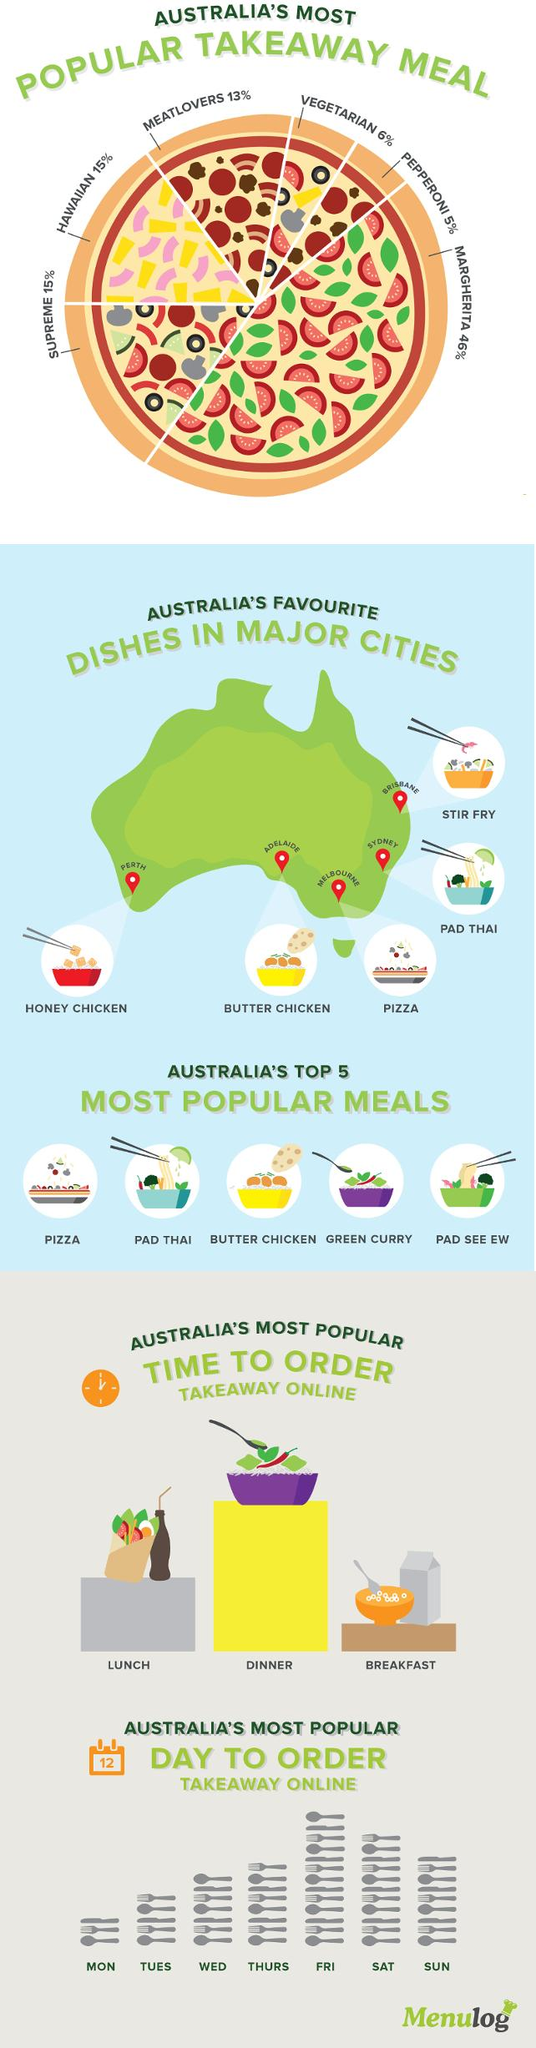Highlight a few significant elements in this photo. It is most common to see 54 spoons, forks, and knives on the day that is typically ordered. According to a survey, 21% of people surveyed prefer vegetarian and Hawaiian pizza. The dish that is most favored by those in Adelaide is butter chicken. In Australia, Friday is the most popular day for ordering takeaways online. The image above shows three spoons. This information is being declared. 